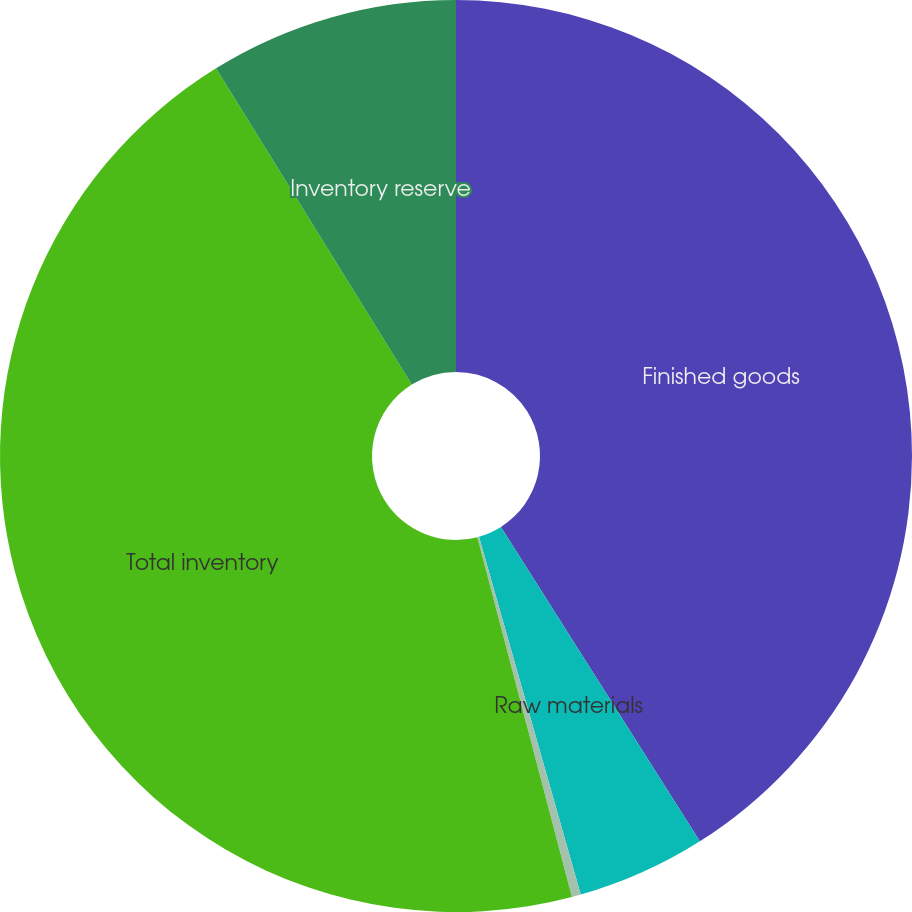Convert chart to OTSL. <chart><loc_0><loc_0><loc_500><loc_500><pie_chart><fcel>Finished goods<fcel>Raw materials<fcel>Work-in-process<fcel>Total inventory<fcel>Inventory reserve<nl><fcel>41.02%<fcel>4.57%<fcel>0.32%<fcel>45.27%<fcel>8.82%<nl></chart> 